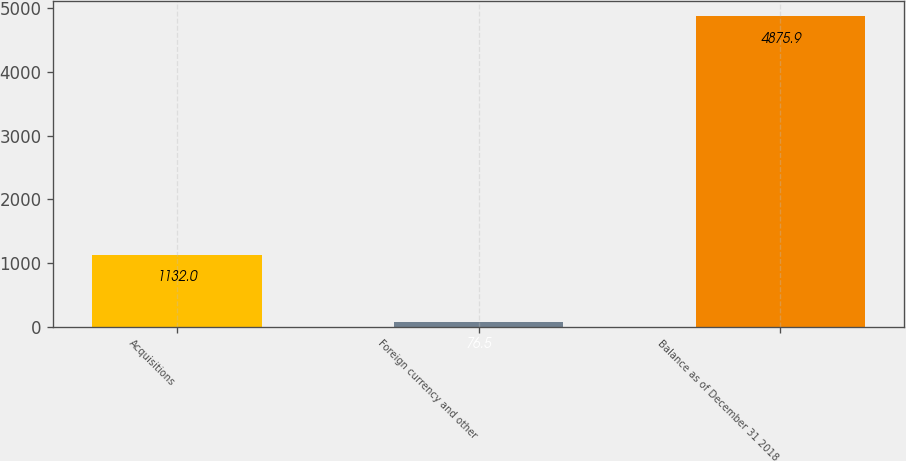<chart> <loc_0><loc_0><loc_500><loc_500><bar_chart><fcel>Acquisitions<fcel>Foreign currency and other<fcel>Balance as of December 31 2018<nl><fcel>1132<fcel>76.5<fcel>4875.9<nl></chart> 